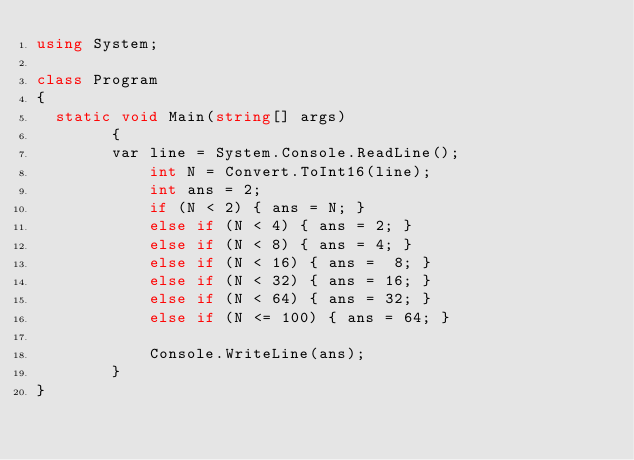<code> <loc_0><loc_0><loc_500><loc_500><_C#_>using System;

class Program
{
	static void Main(string[] args)
        {
		    var line = System.Console.ReadLine();
            int N = Convert.ToInt16(line);
            int ans = 2;
            if (N < 2) { ans = N; }
            else if (N < 4) { ans = 2; }
            else if (N < 8) { ans = 4; }
            else if (N < 16) { ans =  8; }
            else if (N < 32) { ans = 16; }
            else if (N < 64) { ans = 32; }
            else if (N <= 100) { ans = 64; }     

            Console.WriteLine(ans);
        } 
}</code> 